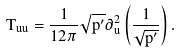Convert formula to latex. <formula><loc_0><loc_0><loc_500><loc_500>T _ { u u } = \frac { 1 } { 1 2 \pi } \sqrt { p ^ { \prime } } \partial _ { u } ^ { 2 } \left ( \frac { 1 } { \sqrt { p ^ { \prime } } } \right ) .</formula> 